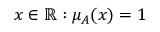Convert formula to latex. <formula><loc_0><loc_0><loc_500><loc_500>x \in \mathbb { R } \colon \mu _ { A } ( x ) = 1</formula> 